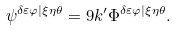<formula> <loc_0><loc_0><loc_500><loc_500>\psi ^ { \delta \varepsilon \varphi | \xi \eta \theta } = 9 k ^ { \prime } \Phi ^ { \delta \varepsilon \varphi | \xi \eta \theta } .</formula> 